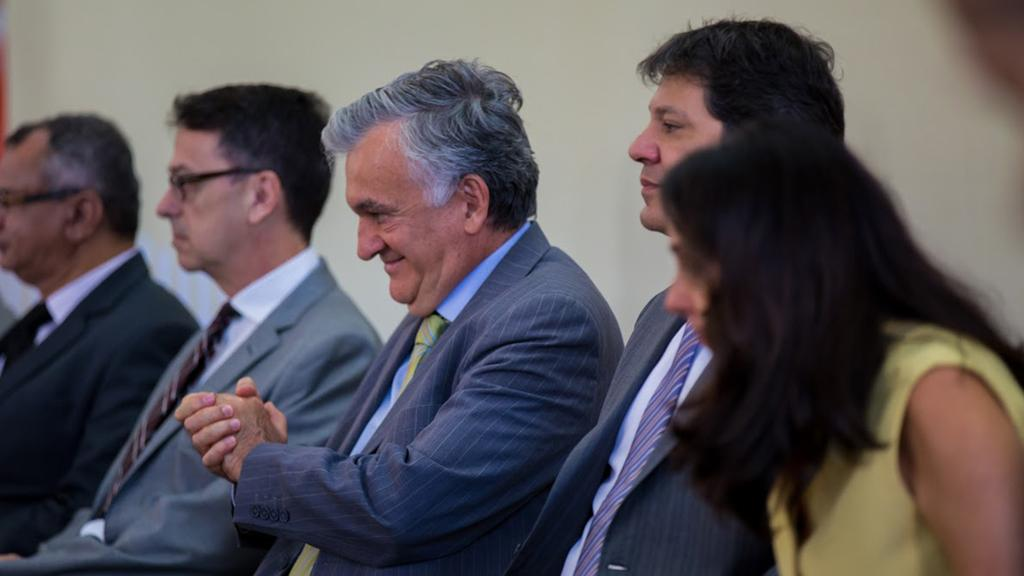What is happening in the foreground of the image? There are people sitting in the foreground of the image. Can you describe the facial expression of one of the people? One person is smiling. What can be seen in the background of the image? There is a wall in the background of the image. What flavor of ice cream are the people fighting over in the image? There is no ice cream or fighting present in the image. 